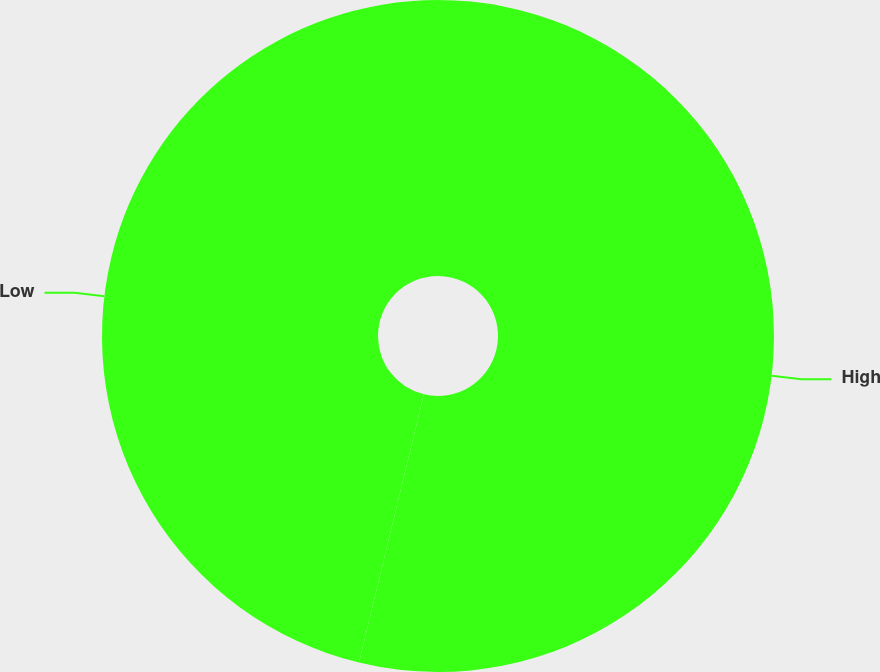<chart> <loc_0><loc_0><loc_500><loc_500><pie_chart><fcel>High<fcel>Low<nl><fcel>53.78%<fcel>46.22%<nl></chart> 